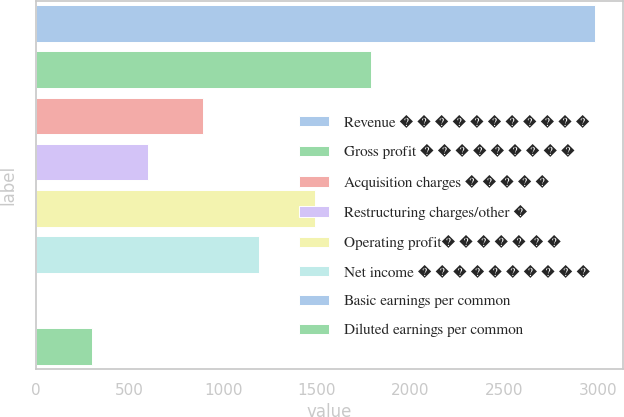<chart> <loc_0><loc_0><loc_500><loc_500><bar_chart><fcel>Revenue � � � � � � � � � � �<fcel>Gross profit � � � � � � � � �<fcel>Acquisition charges � � � � �<fcel>Restructuring charges/other �<fcel>Operating profit� � � � � � �<fcel>Net income � � � � � � � � � �<fcel>Basic earnings per common<fcel>Diluted earnings per common<nl><fcel>2983<fcel>1790<fcel>895.22<fcel>596.96<fcel>1491.74<fcel>1193.48<fcel>0.44<fcel>298.7<nl></chart> 